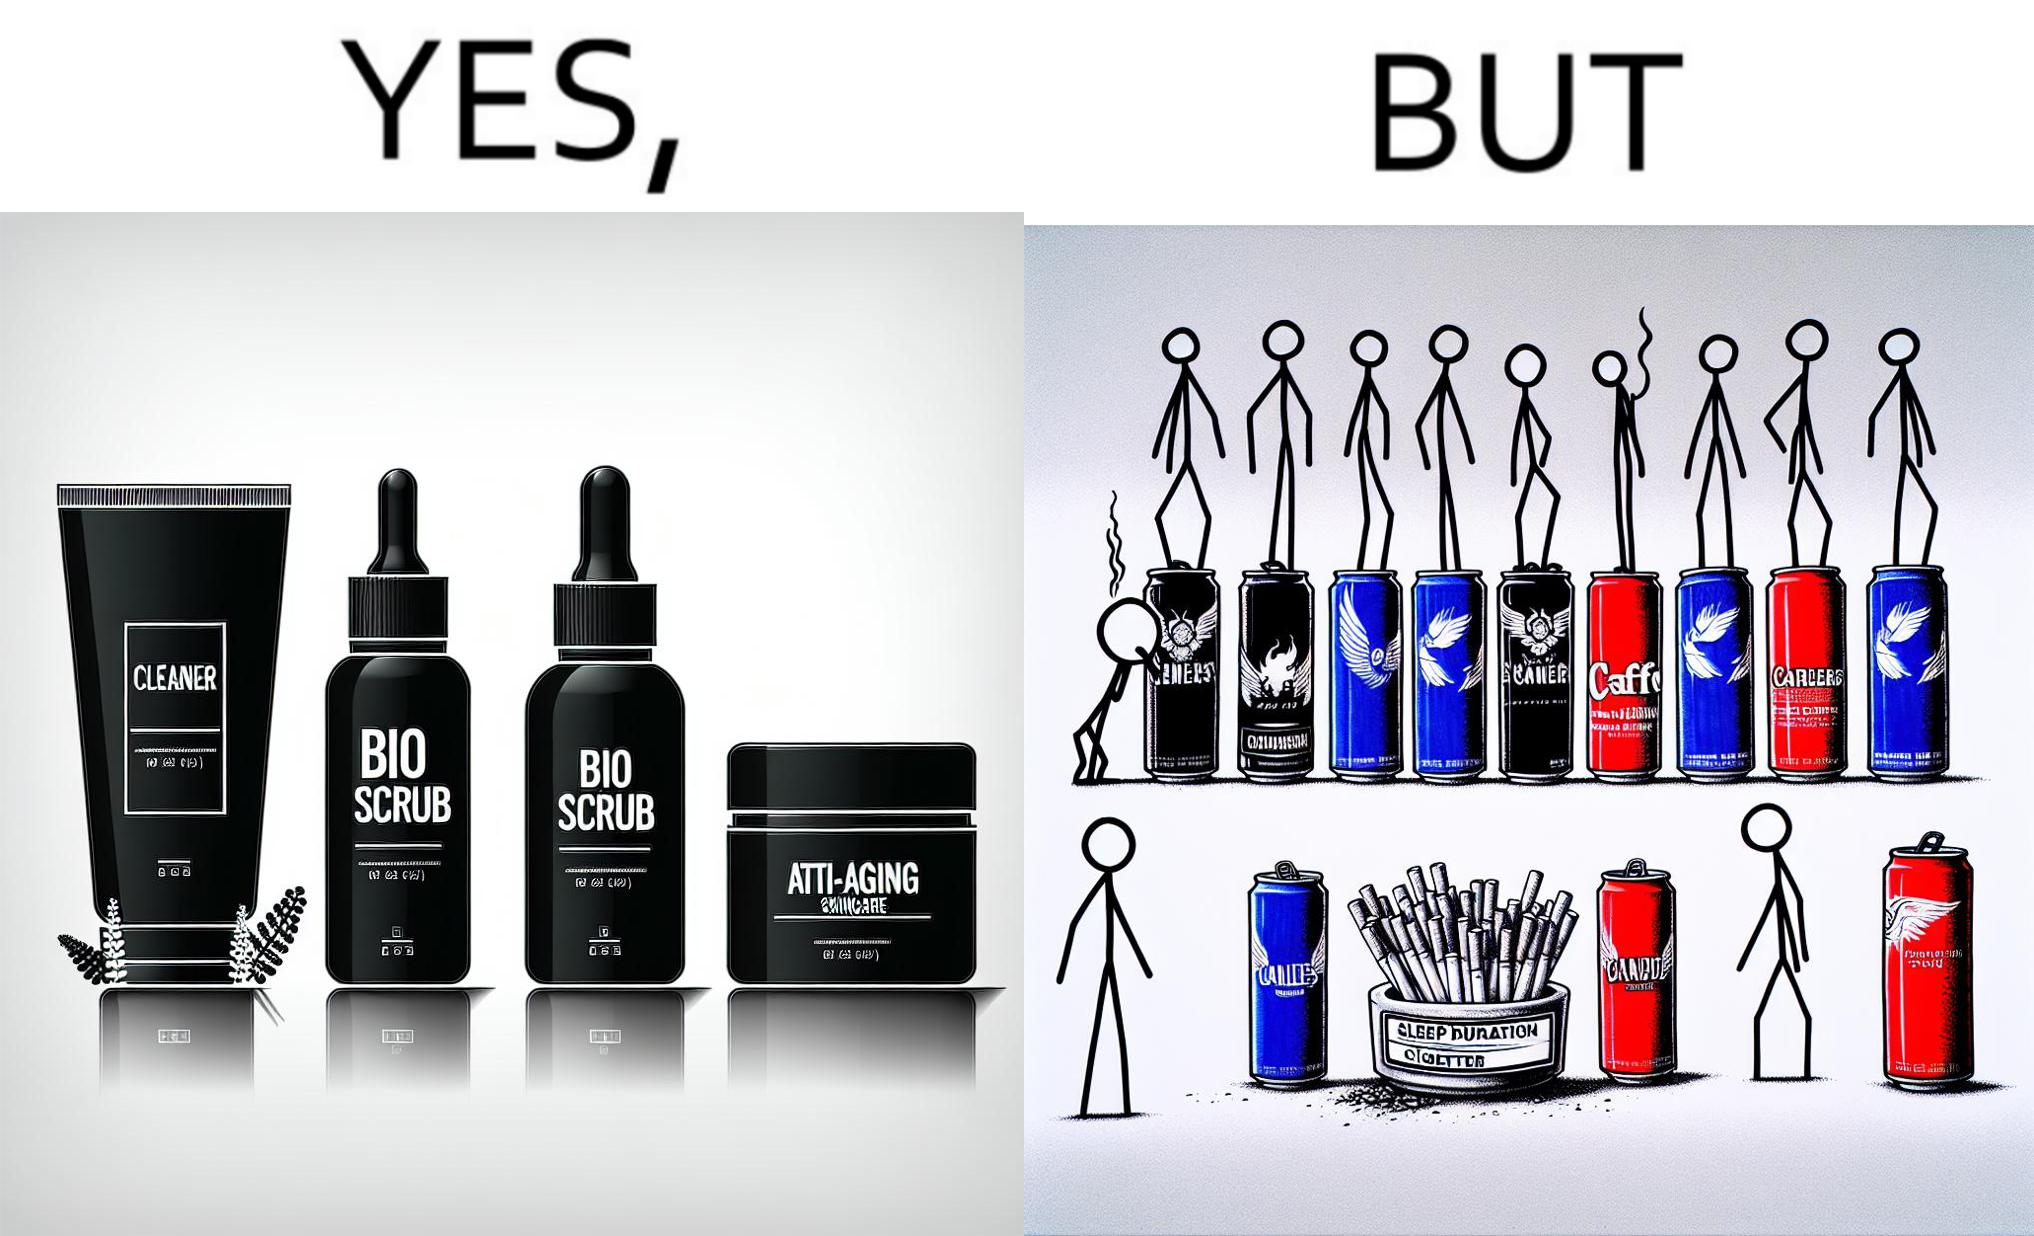What does this image depict? This image is ironic as on the one hand, the presumed person is into skincare and wants to do the best for their skin, which is good, but on the other hand, they are involved in unhealthy habits that will damage their skin like smoking, caffeine and inadequate sleep. 